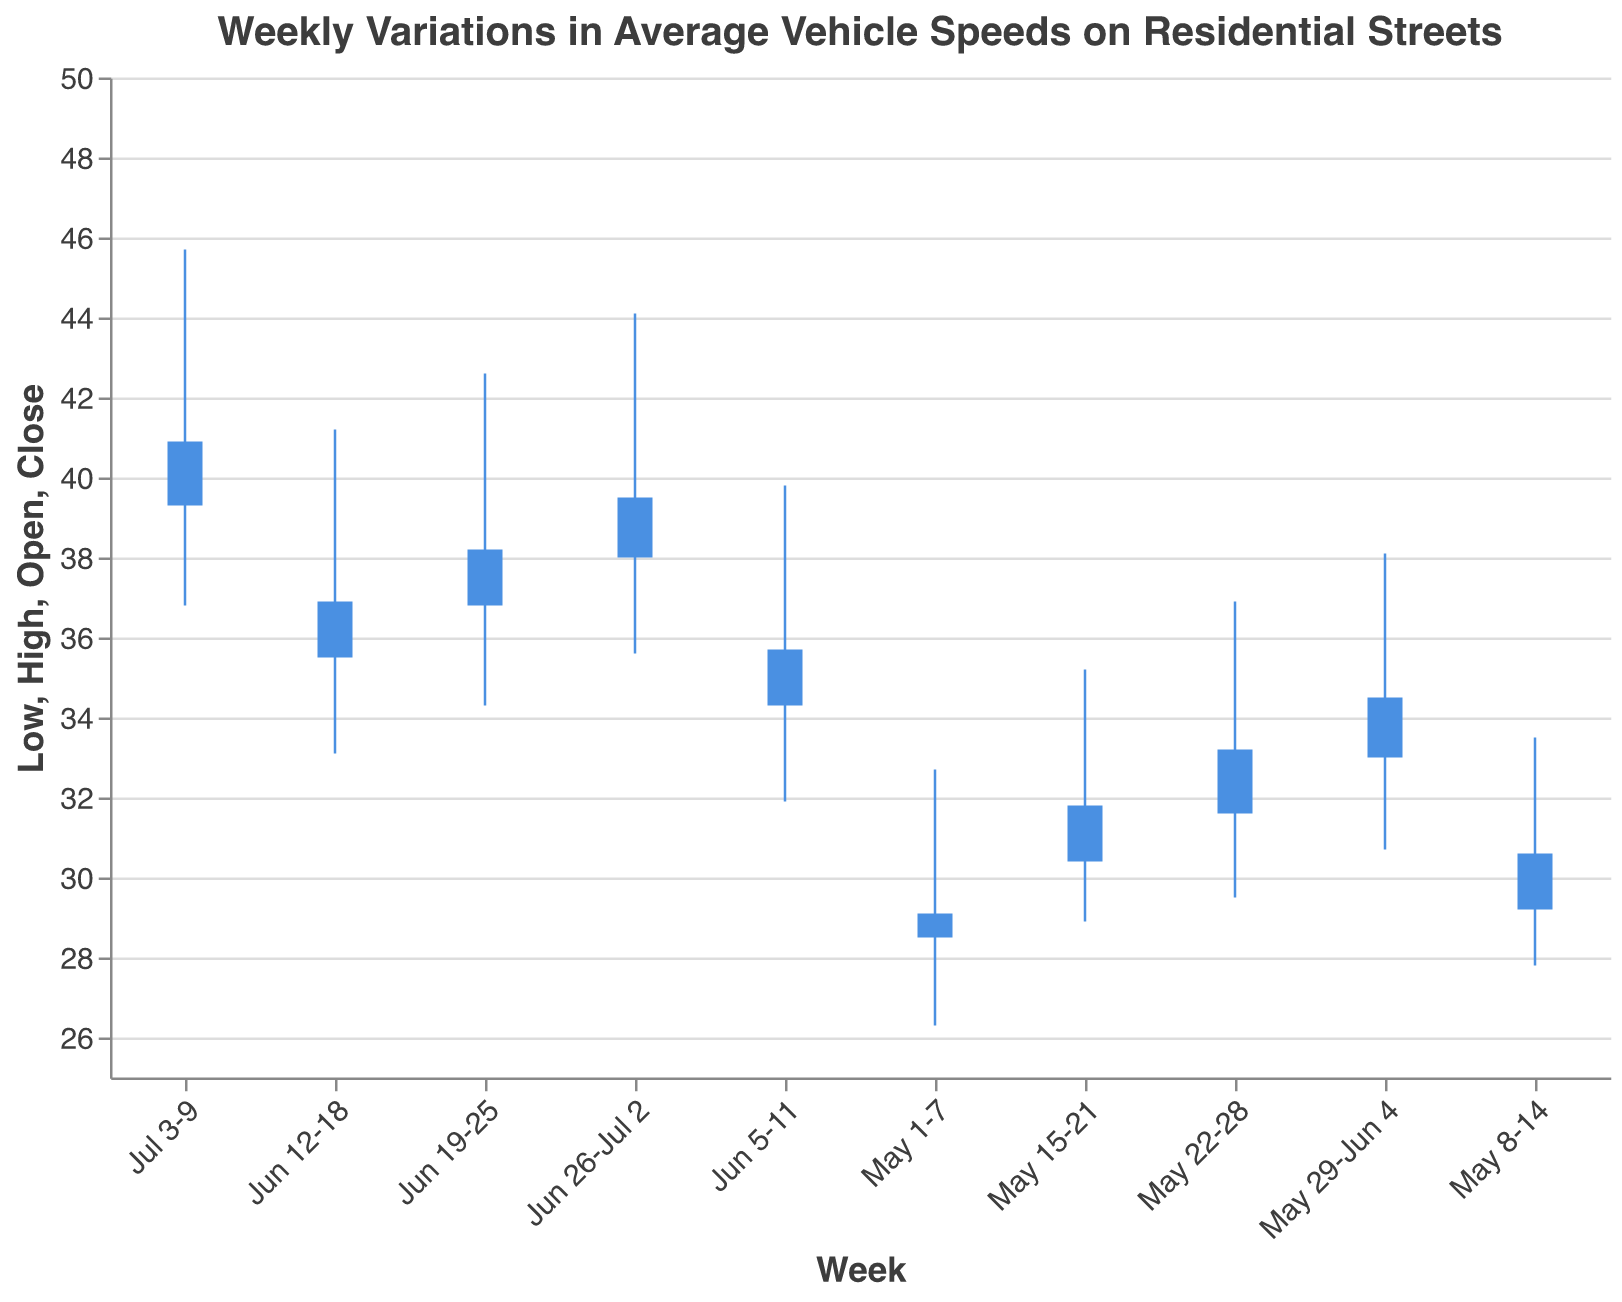What is the title of the chart? The title is usually at the top of the chart and is often in a larger or bold font. It gives a brief summary of what the data represents.
Answer: Weekly Variations in Average Vehicle Speeds on Residential Streets What are the highest and lowest speed values recorded in the week of Jun 19-25? For Jun 19-25, the highest value is marked by the top of the highest rule line, and the lowest value is marked by the bottom of the lowest rule line.
Answer: 42.6 (high) and 34.3 (low) Between which weeks did the average vehicle speeds show the highest increase in closing speed? Compare the closing speeds (Close) of each week and identify the largest positive difference. The highest increase can be seen by the larger rise in the bar of subsequent weeks.
Answer: Jun 12-18 to Jun 19-25 What is the trend of the closing speeds from May 1-7 to Jul 3-9? Look at the height of the bars, specifically their top and bottom lines associated with the 'Close' values across the weeks. Notice if there's an overall increase, decrease, or consistency.
Answer: Increasing trend Which week had the highest average speed (Open value) and what was it? Identify the week with the tallest 'Open' bar and read the corresponding value.
Answer: Jul 3-9; 39.3 How does the range of speeds (difference between High and Low) change from May 1-7 to Jul 3-9? Calculate the range (High - Low) for each week and observe the changes over time. Note any trends in these differences.
Answer: The range increased over time In which week was the highest maximum speed recorded and what was it? Identify the highest peak in all the rule lines and read off the associated week and value.
Answer: Jul 3-9; 45.7 What was the lowest closing speed recorded, and in which week? Look for the shortest height on the closing (bottom) side of the bar and check its corresponding week and value.
Answer: May 1-7; 29.1 Between May 1-7 and Jul 3-9, in which trio of consecutive weeks did the opening speeds show a steady increase? Check consecutive weeks' (Open) bars and find a trio where each successive week tallies higher than the previous
Answer: Between May 29-Jun 4 and Jun 19-25 What weeks had close values that were higher than their open values? Compare the Open and Close values of each week and see which ones have the bottom line of the bar higher than the top line.
Answer: May 8-14, May 15-21, May 22-28, Jun 5-11, Jun 19-25, Jul 3-9 